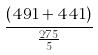Convert formula to latex. <formula><loc_0><loc_0><loc_500><loc_500>\frac { ( 4 9 1 + 4 4 1 ) } { \frac { 2 7 5 } { 5 } }</formula> 